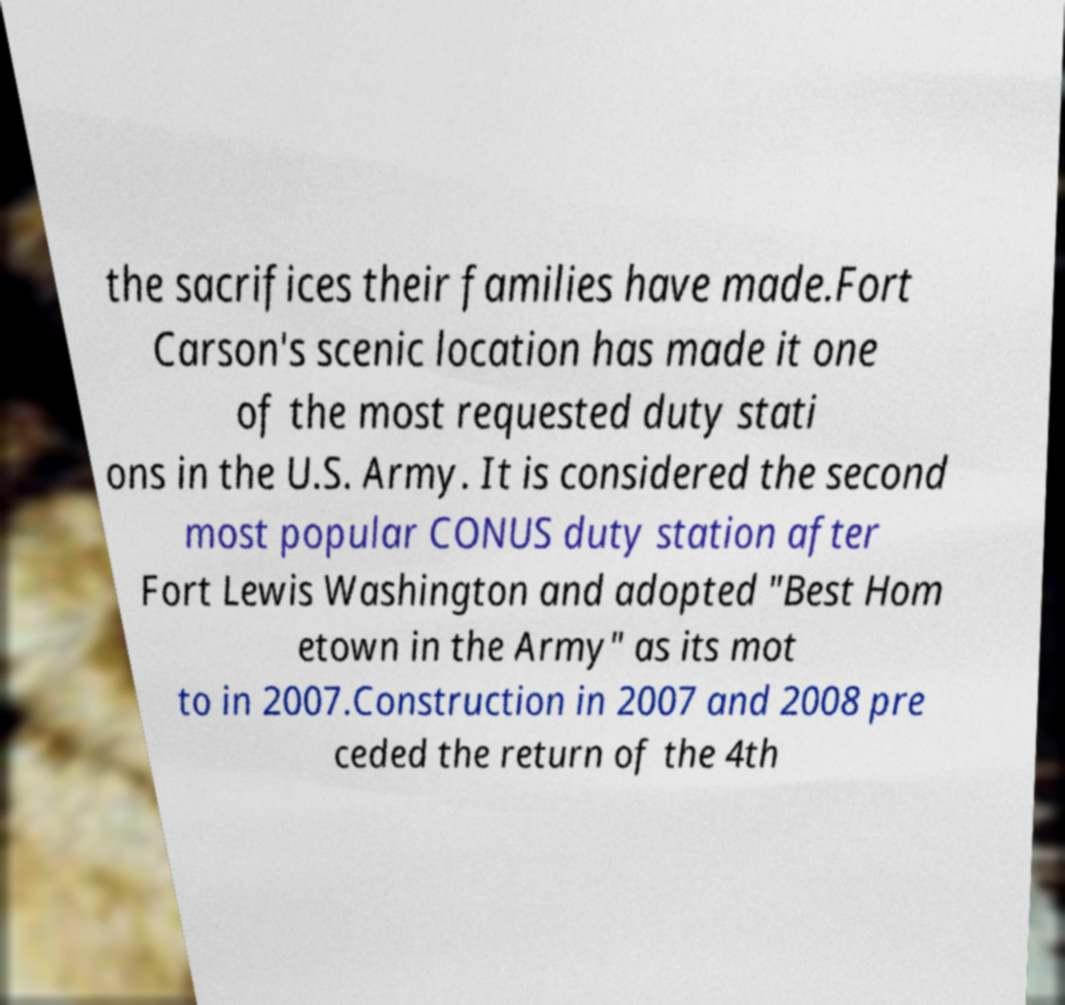Could you assist in decoding the text presented in this image and type it out clearly? the sacrifices their families have made.Fort Carson's scenic location has made it one of the most requested duty stati ons in the U.S. Army. It is considered the second most popular CONUS duty station after Fort Lewis Washington and adopted "Best Hom etown in the Army" as its mot to in 2007.Construction in 2007 and 2008 pre ceded the return of the 4th 